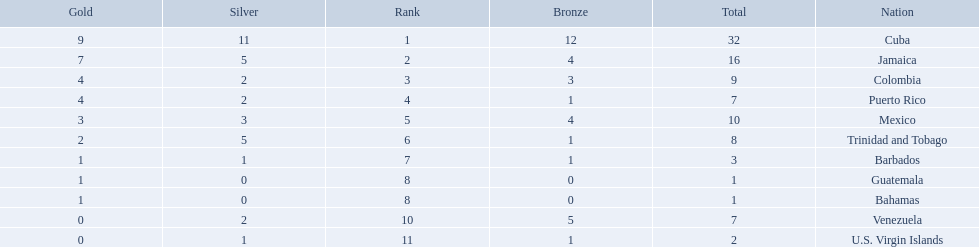What nation has won at least 4 gold medals? Cuba, Jamaica, Colombia, Puerto Rico. Of these countries who has won the least amount of bronze medals? Puerto Rico. 